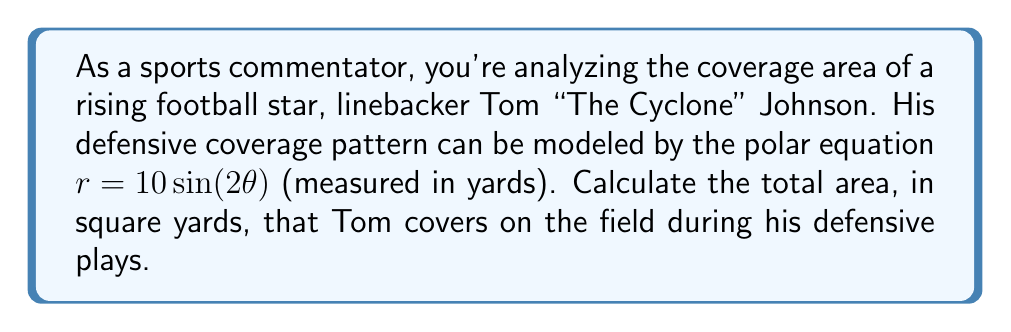Solve this math problem. To solve this problem, we need to use the formula for the area enclosed by a polar curve. The area $A$ enclosed by a polar curve $r = f(\theta)$ from $\theta = a$ to $\theta = b$ is given by:

$$A = \frac{1}{2} \int_{a}^{b} [f(\theta)]^2 d\theta$$

For Tom's coverage pattern, we have $r = 10 \sin(2\theta)$. The curve completes one full cycle when $\theta$ goes from 0 to $\pi$. So, we need to integrate from 0 to $\pi$:

$$A = \frac{1}{2} \int_{0}^{\pi} [10 \sin(2\theta)]^2 d\theta$$

Simplifying the integrand:
$$A = 50 \int_{0}^{\pi} \sin^2(2\theta) d\theta$$

We can use the trigonometric identity $\sin^2(2\theta) = \frac{1}{2}(1 - \cos(4\theta))$:

$$A = 50 \int_{0}^{\pi} \frac{1}{2}(1 - \cos(4\theta)) d\theta$$
$$A = 25 \int_{0}^{\pi} (1 - \cos(4\theta)) d\theta$$
$$A = 25 [\theta - \frac{1}{4}\sin(4\theta)]_{0}^{\pi}$$

Evaluating the integral:
$$A = 25 [(\pi - 0) - (\frac{1}{4}\sin(4\pi) - \frac{1}{4}\sin(0))]$$
$$A = 25\pi$$

Therefore, the total area Tom covers is $25\pi$ square yards.
Answer: $25\pi$ square yards 